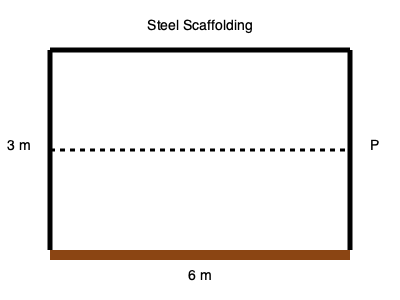As a homeowner overseeing a renovation project, you need to ensure the safety of workers using scaffolding. Given a steel scaffolding structure with a width of 6 m and a height of 3 m, calculate the maximum safe load capacity (P) in kN that can be applied at the center of the top beam. Assume the following material properties for the steel:

- Yield strength: $\sigma_y = 250$ MPa
- Safety factor: $SF = 2$
- Moment of inertia of the top beam: $I = 2 \times 10^{-5}$ m⁴
- Young's modulus: $E = 200$ GPa To calculate the safe load capacity, we'll follow these steps:

1) The maximum bending moment occurs at the center of the beam and is given by:
   $M_{max} = \frac{PL}{4}$, where L is the length of the beam (6 m)

2) The maximum stress in the beam is related to the moment by:
   $\sigma_{max} = \frac{M_{max}y}{I}$, where y is the distance from the neutral axis to the outer fiber (assume y = 0.1 m)

3) For safety, we want: $\sigma_{max} \leq \frac{\sigma_y}{SF}$

4) Substituting and solving for P:

   $\frac{\sigma_y}{SF} = \frac{(PL/4)y}{I}$

   $P = \frac{4I\sigma_y}{SFLy}$

5) Plugging in the values:

   $P = \frac{4 \cdot (2 \times 10^{-5}) \cdot (250 \times 10^6)}{2 \cdot 6 \cdot 0.1}$

6) Calculating:
   $P = 16,666.67$ N $\approx 16.67$ kN

Therefore, the maximum safe load capacity is approximately 16.67 kN.
Answer: 16.67 kN 